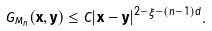Convert formula to latex. <formula><loc_0><loc_0><loc_500><loc_500>G _ { M _ { n } } ( \mathbf x , \mathbf y ) \leq C | \mathbf x - \mathbf y | ^ { 2 - \xi - ( n - 1 ) d } .</formula> 